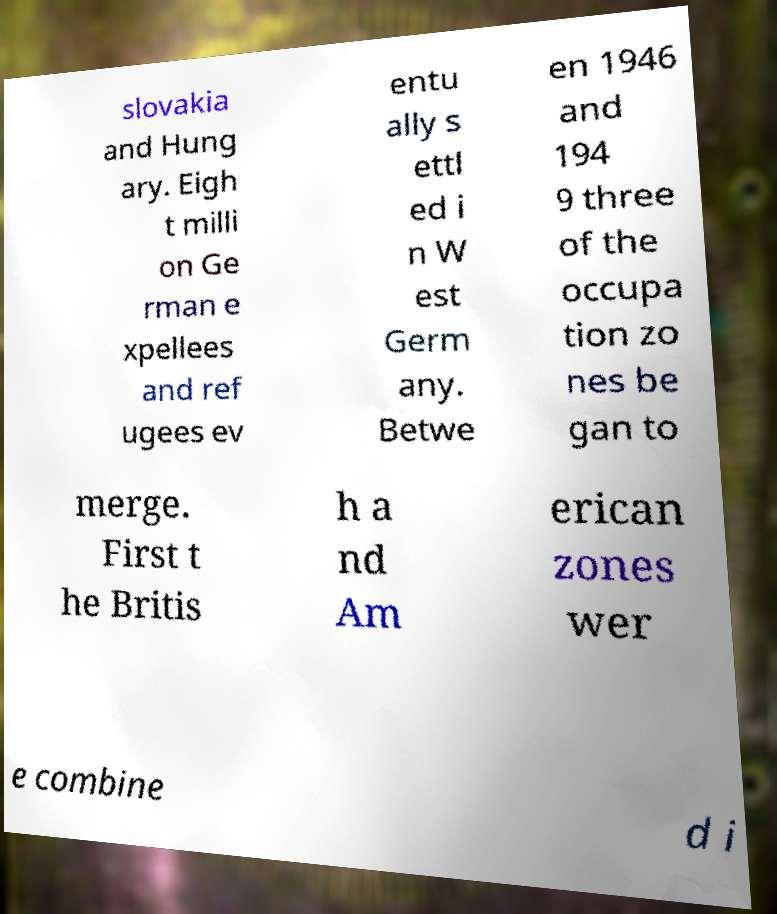Please identify and transcribe the text found in this image. slovakia and Hung ary. Eigh t milli on Ge rman e xpellees and ref ugees ev entu ally s ettl ed i n W est Germ any. Betwe en 1946 and 194 9 three of the occupa tion zo nes be gan to merge. First t he Britis h a nd Am erican zones wer e combine d i 